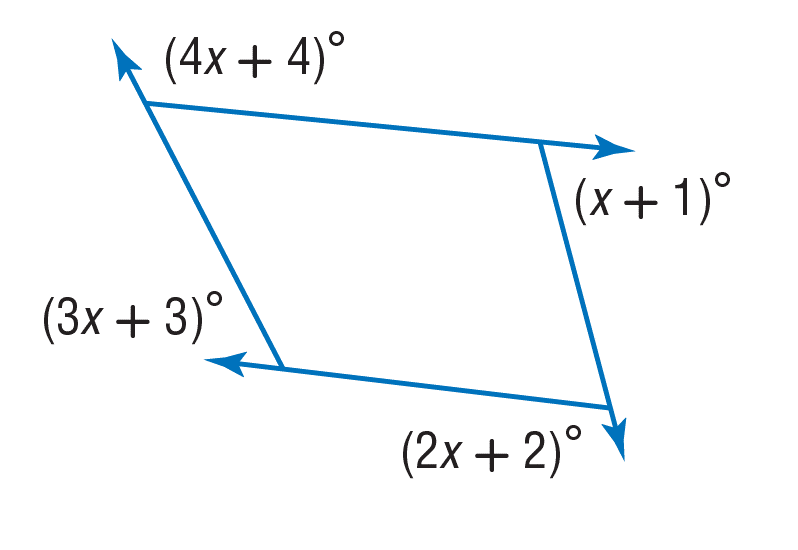Answer the mathemtical geometry problem and directly provide the correct option letter.
Question: Find the value of x.
Choices: A: 35 B: 36 C: 70 D: 180 A 